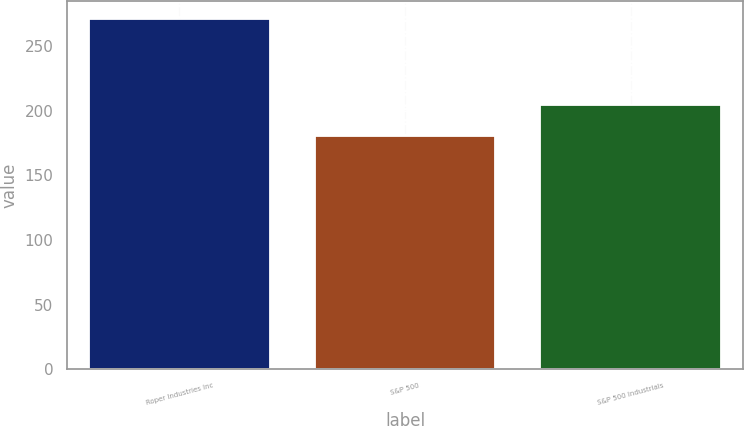Convert chart to OTSL. <chart><loc_0><loc_0><loc_500><loc_500><bar_chart><fcel>Roper Industries Inc<fcel>S&P 500<fcel>S&P 500 Industrials<nl><fcel>271.02<fcel>180.44<fcel>204.43<nl></chart> 